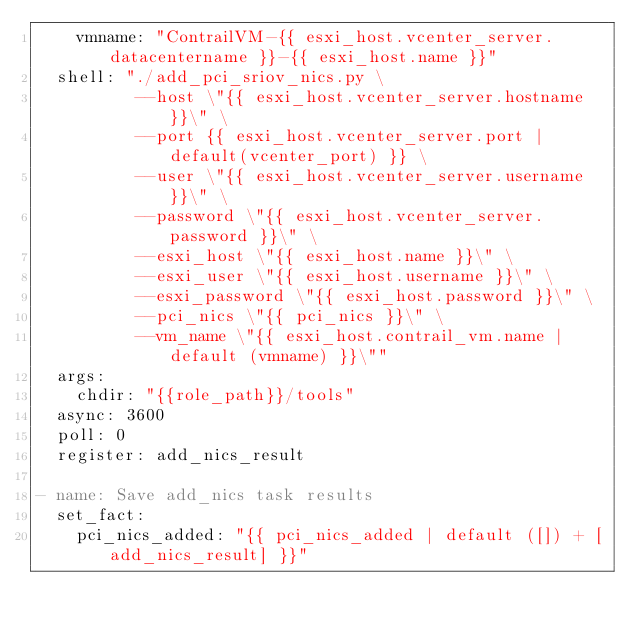Convert code to text. <code><loc_0><loc_0><loc_500><loc_500><_YAML_>    vmname: "ContrailVM-{{ esxi_host.vcenter_server.datacentername }}-{{ esxi_host.name }}"
  shell: "./add_pci_sriov_nics.py \
          --host \"{{ esxi_host.vcenter_server.hostname }}\" \
          --port {{ esxi_host.vcenter_server.port | default(vcenter_port) }} \
          --user \"{{ esxi_host.vcenter_server.username }}\" \
          --password \"{{ esxi_host.vcenter_server.password }}\" \
          --esxi_host \"{{ esxi_host.name }}\" \
          --esxi_user \"{{ esxi_host.username }}\" \
          --esxi_password \"{{ esxi_host.password }}\" \
          --pci_nics \"{{ pci_nics }}\" \
          --vm_name \"{{ esxi_host.contrail_vm.name | default (vmname) }}\""
  args:
    chdir: "{{role_path}}/tools"
  async: 3600
  poll: 0
  register: add_nics_result

- name: Save add_nics task results
  set_fact:
    pci_nics_added: "{{ pci_nics_added | default ([]) + [add_nics_result] }}"
</code> 